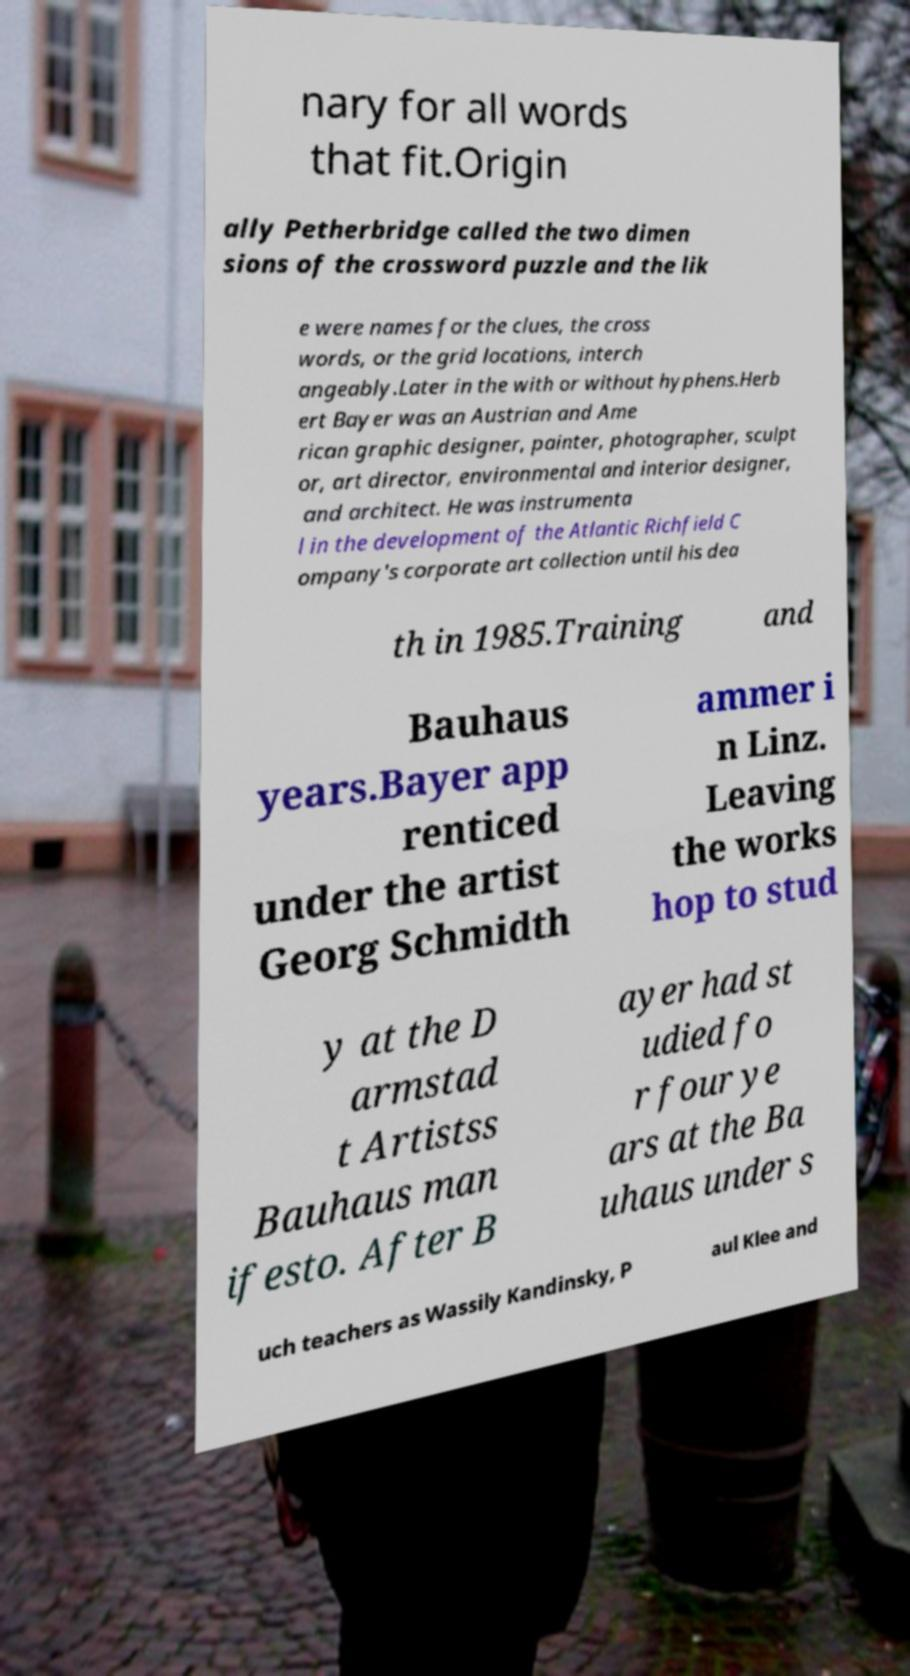Can you accurately transcribe the text from the provided image for me? nary for all words that fit.Origin ally Petherbridge called the two dimen sions of the crossword puzzle and the lik e were names for the clues, the cross words, or the grid locations, interch angeably.Later in the with or without hyphens.Herb ert Bayer was an Austrian and Ame rican graphic designer, painter, photographer, sculpt or, art director, environmental and interior designer, and architect. He was instrumenta l in the development of the Atlantic Richfield C ompany's corporate art collection until his dea th in 1985.Training and Bauhaus years.Bayer app renticed under the artist Georg Schmidth ammer i n Linz. Leaving the works hop to stud y at the D armstad t Artistss Bauhaus man ifesto. After B ayer had st udied fo r four ye ars at the Ba uhaus under s uch teachers as Wassily Kandinsky, P aul Klee and 